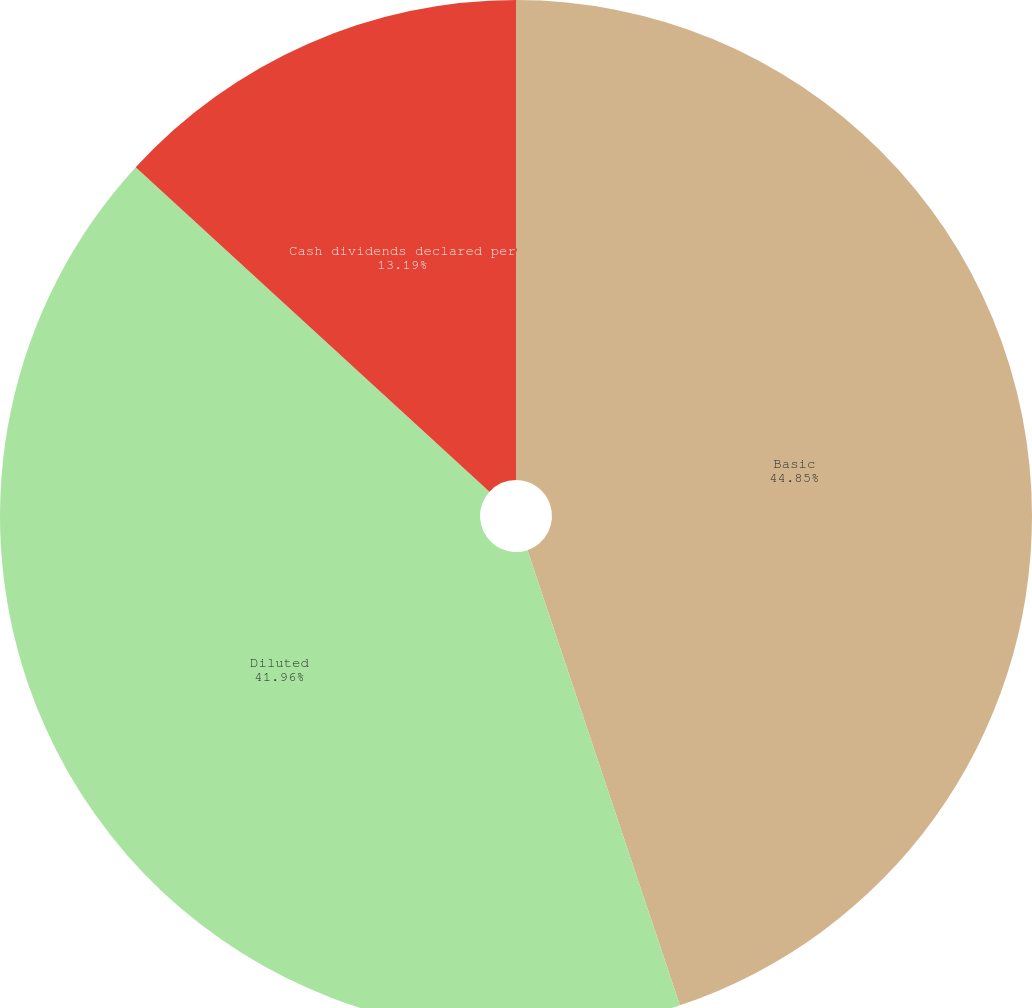<chart> <loc_0><loc_0><loc_500><loc_500><pie_chart><fcel>Basic<fcel>Diluted<fcel>Cash dividends declared per<nl><fcel>44.86%<fcel>41.96%<fcel>13.19%<nl></chart> 